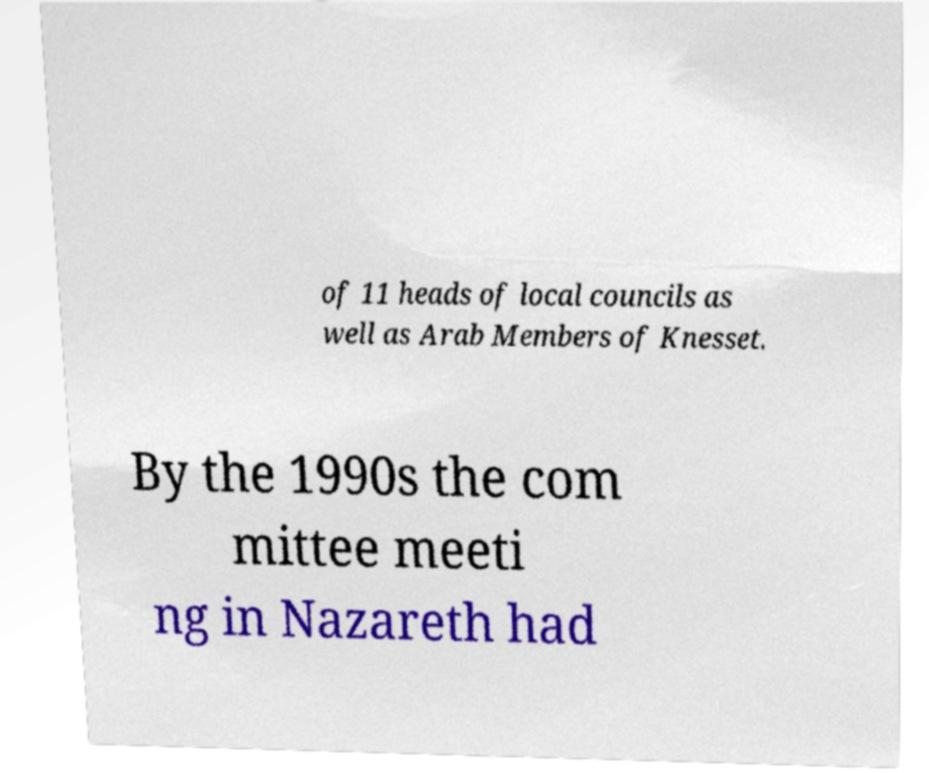Please identify and transcribe the text found in this image. of 11 heads of local councils as well as Arab Members of Knesset. By the 1990s the com mittee meeti ng in Nazareth had 